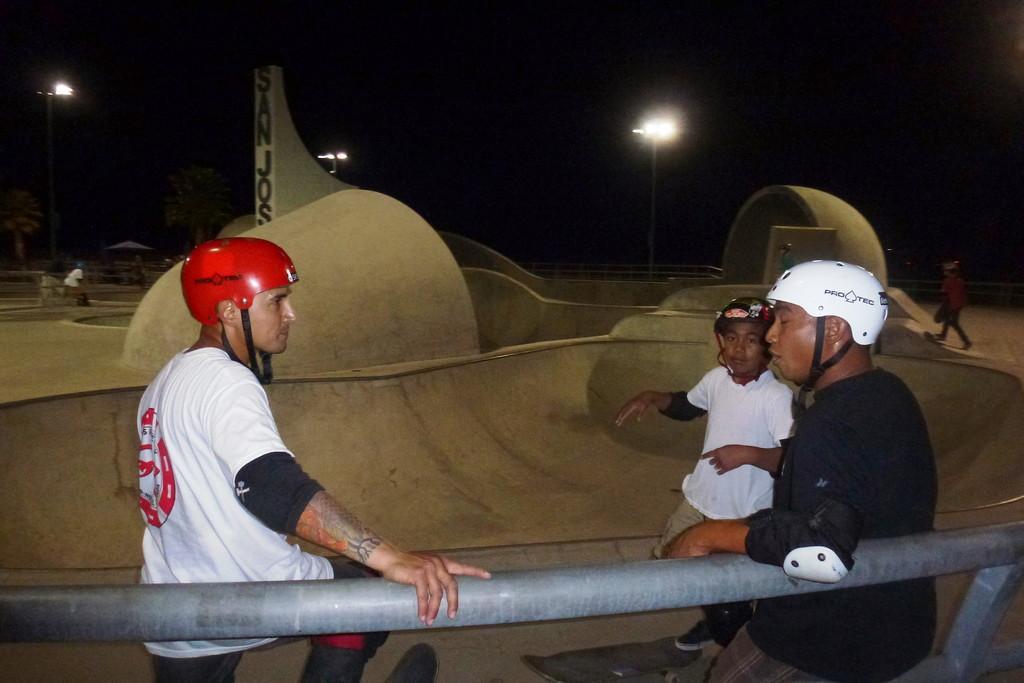Please provide a concise description of this image. In this picture there is a man wearing white color t-shirt and red helmet standing and talking to the beside person wearing a black color t-shirt and white color helmet. Behind we can see the skating board ramp. Behind there is a black background and sheet lights. 